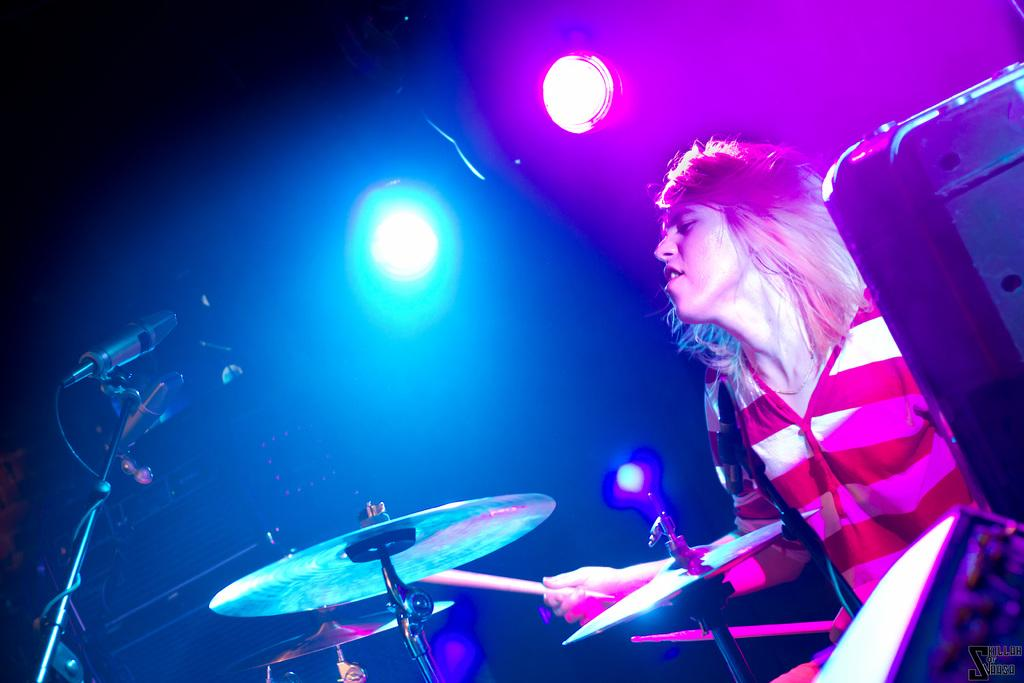What is the main subject of the image? There is a person in the image. What is the person holding in their hands? The person is holding sticks in their hands. What is the person doing with the sticks? The person is hitting cymbals with the sticks. What other objects can be seen in the image? There are lights visible in the image, as well as a microphone (mic). How would you describe the background of the image? The background of the image is dark. What type of note is the person holding in their hand? There is no note present in the image; the person is holding sticks. What kind of pest can be seen crawling on the microphone in the image? There are no pests visible in the image, and the microphone is not shown close enough for any pests to be observed. 